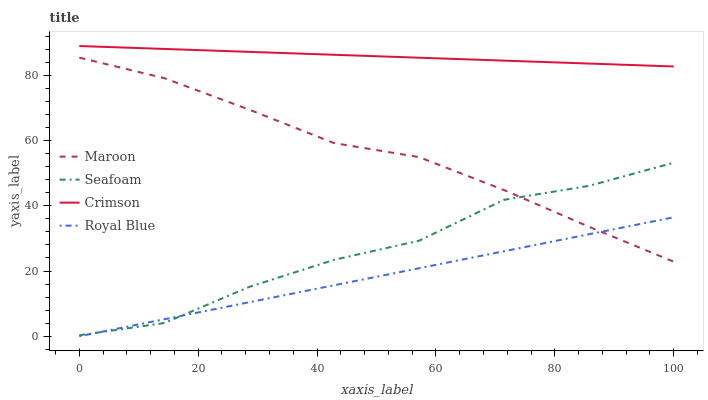Does Royal Blue have the minimum area under the curve?
Answer yes or no. Yes. Does Crimson have the maximum area under the curve?
Answer yes or no. Yes. Does Seafoam have the minimum area under the curve?
Answer yes or no. No. Does Seafoam have the maximum area under the curve?
Answer yes or no. No. Is Crimson the smoothest?
Answer yes or no. Yes. Is Seafoam the roughest?
Answer yes or no. Yes. Is Royal Blue the smoothest?
Answer yes or no. No. Is Royal Blue the roughest?
Answer yes or no. No. Does Royal Blue have the lowest value?
Answer yes or no. Yes. Does Seafoam have the lowest value?
Answer yes or no. No. Does Crimson have the highest value?
Answer yes or no. Yes. Does Seafoam have the highest value?
Answer yes or no. No. Is Royal Blue less than Crimson?
Answer yes or no. Yes. Is Crimson greater than Seafoam?
Answer yes or no. Yes. Does Seafoam intersect Royal Blue?
Answer yes or no. Yes. Is Seafoam less than Royal Blue?
Answer yes or no. No. Is Seafoam greater than Royal Blue?
Answer yes or no. No. Does Royal Blue intersect Crimson?
Answer yes or no. No. 